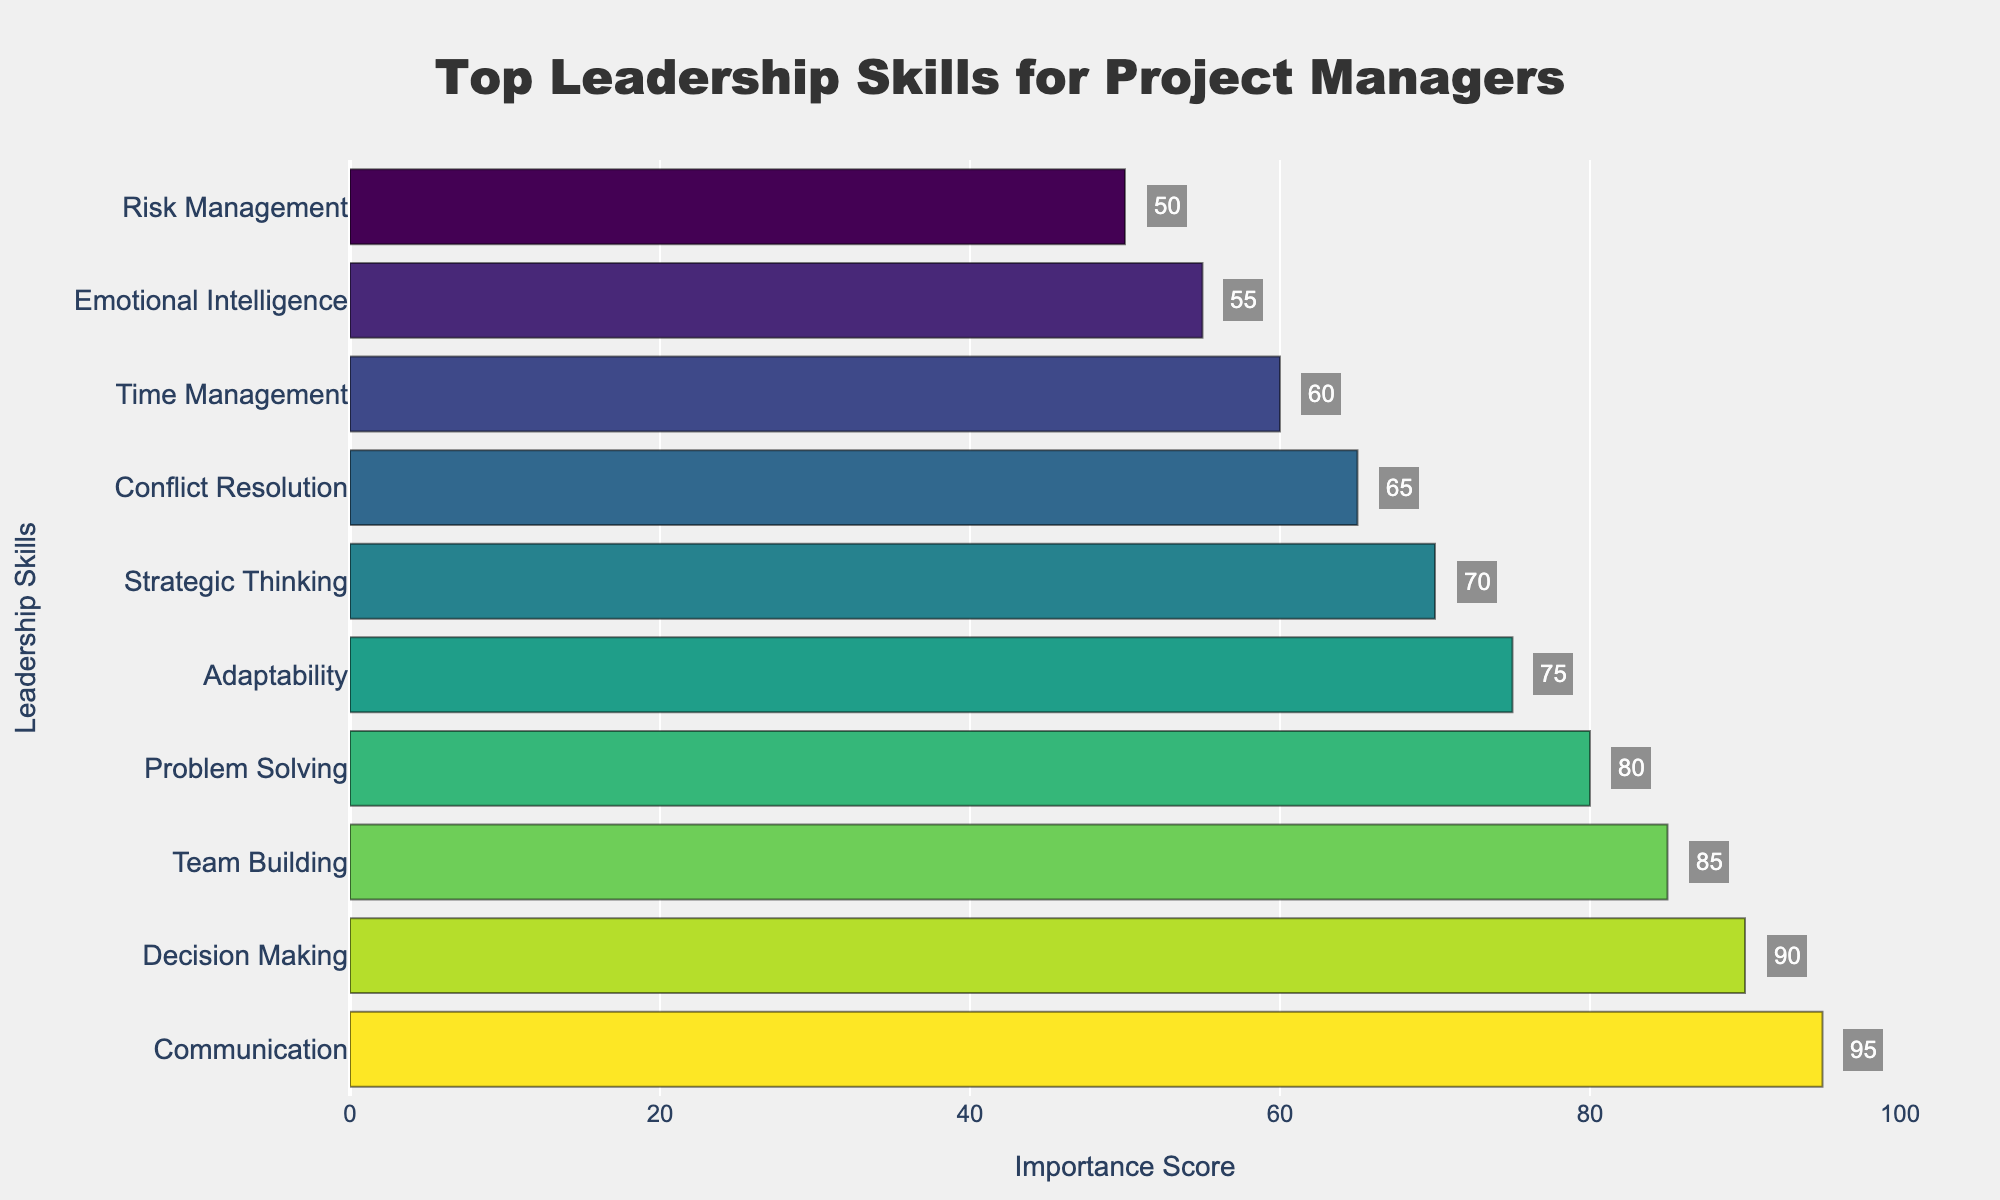What is the most important leadership skill for project managers according to the chart? The most important skill appears at the top with the highest importance score. By looking at the top bar, we can see that "Communication" has the highest importance score.
Answer: Communication Which skill has the lowest importance score in the chart? The skill with the lowest importance score is at the bottom of the chart. "Risk Management" is the last listed skill and has the lowest score of 50.
Answer: Risk Management What is the impact score difference between the topmost and the least important skill? Find the importance score of the topmost skill ("Communication" with 95) and the least important skill ("Risk Management" with 50), then calculate the difference: 95 - 50.
Answer: 45 How do the scores of Team Building and Problem Solving compare? Look at the importance scores of "Team Building" (85) and "Problem Solving" (80), and compare them to see that Team Building has a higher score than Problem Solving.
Answer: Team Building is higher Which skills have their importance scores between 70 and 90? Identify the skills whose importance scores fall within the range of 70 to 90 by scanning through the bars. These skills are "Decision Making" (90), "Team Building" (85), "Problem Solving" (80), and "Adaptability" (75).
Answer: Decision Making, Team Building, Problem Solving, and Adaptability What is the combined importance score of the top two skills? Sum the importance scores of the top two skills: "Communication" (95) and "Decision Making" (90). 95 + 90 = 185.
Answer: 185 Which skill is ranked third in terms of importance? The third skill from the top in the chart holds the third highest importance score. "Team Building" is the third skill on the chart.
Answer: Team Building What is the average importance score of the skills listed in the chart? Add up all the importance scores (95 + 90 + 85 + 80 + 75 + 70 + 65 + 60 + 55 + 50 = 725) and then divide by the number of skills (10). 725 / 10 = 72.5.
Answer: 72.5 Which skill has an importance score that is halfway between the scores of "Communication" and "Risk Management"? Calculate the halfway value between "Communication" (95) and "Risk Management" (50): (95 + 50) / 2 = 72.5. Identify the skill closest to this value, which is "Strategic Thinking" with a score of 70.
Answer: Strategic Thinking 